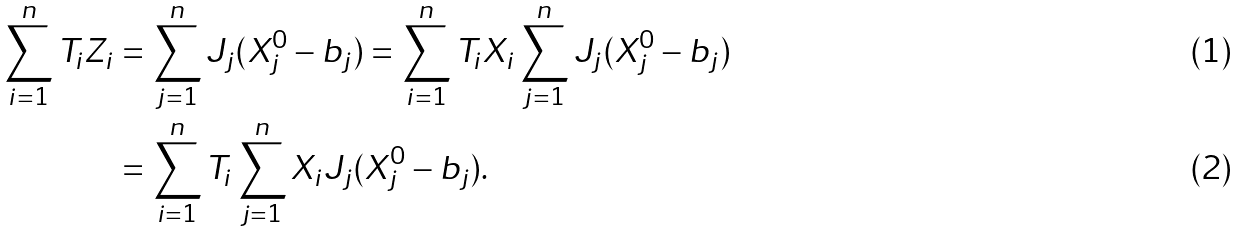Convert formula to latex. <formula><loc_0><loc_0><loc_500><loc_500>\sum _ { i = 1 } ^ { n } T _ { i } Z _ { i } & = \sum _ { j = 1 } ^ { n } J _ { j } ( X ^ { 0 } _ { j } - b _ { j } ) = \sum _ { i = 1 } ^ { n } T _ { i } X _ { i } \sum _ { j = 1 } ^ { n } J _ { j } ( X ^ { 0 } _ { j } - b _ { j } ) \\ & = \sum _ { i = 1 } ^ { n } T _ { i } \sum _ { j = 1 } ^ { n } X _ { i } J _ { j } ( X ^ { 0 } _ { j } - b _ { j } ) .</formula> 